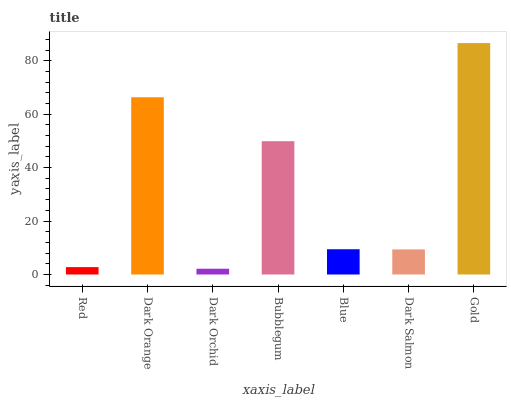Is Dark Orchid the minimum?
Answer yes or no. Yes. Is Gold the maximum?
Answer yes or no. Yes. Is Dark Orange the minimum?
Answer yes or no. No. Is Dark Orange the maximum?
Answer yes or no. No. Is Dark Orange greater than Red?
Answer yes or no. Yes. Is Red less than Dark Orange?
Answer yes or no. Yes. Is Red greater than Dark Orange?
Answer yes or no. No. Is Dark Orange less than Red?
Answer yes or no. No. Is Blue the high median?
Answer yes or no. Yes. Is Blue the low median?
Answer yes or no. Yes. Is Dark Salmon the high median?
Answer yes or no. No. Is Dark Orchid the low median?
Answer yes or no. No. 